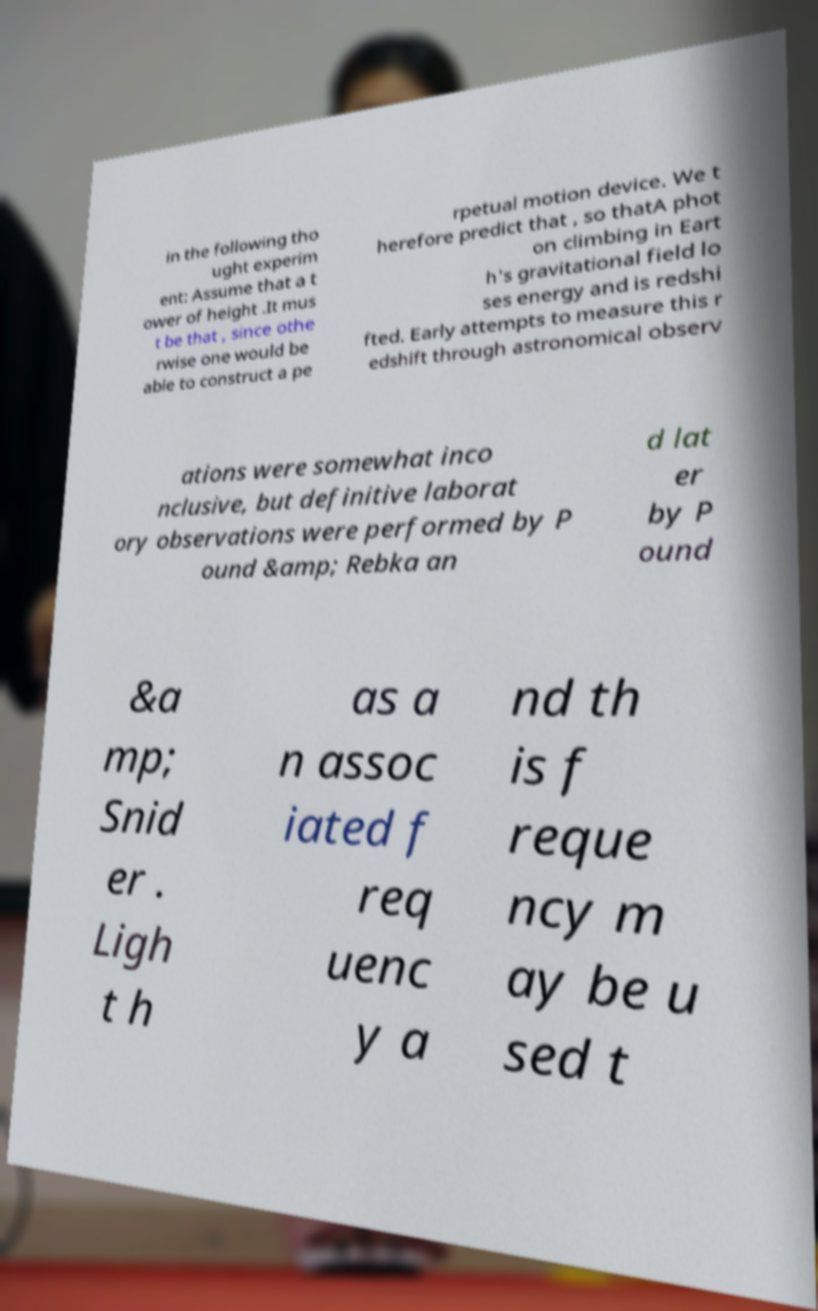Can you accurately transcribe the text from the provided image for me? in the following tho ught experim ent: Assume that a t ower of height .It mus t be that , since othe rwise one would be able to construct a pe rpetual motion device. We t herefore predict that , so thatA phot on climbing in Eart h's gravitational field lo ses energy and is redshi fted. Early attempts to measure this r edshift through astronomical observ ations were somewhat inco nclusive, but definitive laborat ory observations were performed by P ound &amp; Rebka an d lat er by P ound &a mp; Snid er . Ligh t h as a n assoc iated f req uenc y a nd th is f reque ncy m ay be u sed t 